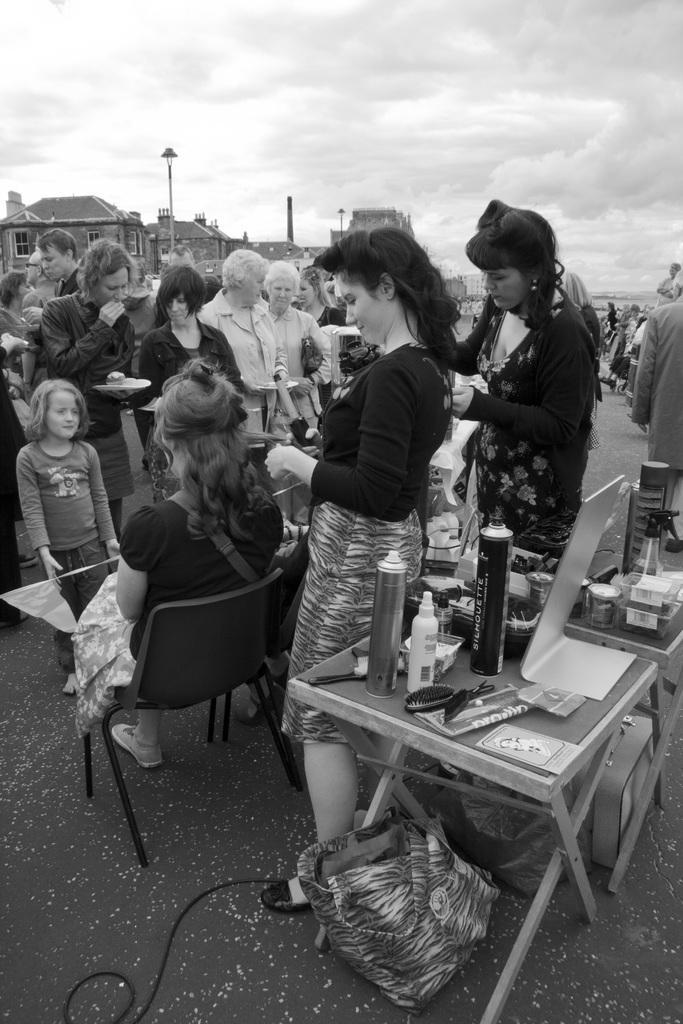Describe this image in one or two sentences. The image is outside the city. In the image there are two people both women are standing behind the table. On table we can see tin,board,comb,hairspray,bottle on left side we can also see a woman sitting on chair. In background there are group of people standing and walking and we can also see some buildings,street light and sky is on top. 